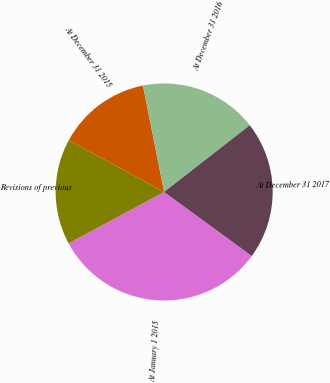Convert chart. <chart><loc_0><loc_0><loc_500><loc_500><pie_chart><fcel>At January 1 2015<fcel>Revisions of previous<fcel>At December 31 2015<fcel>At December 31 2016<fcel>At December 31 2017<nl><fcel>32.1%<fcel>15.77%<fcel>13.96%<fcel>17.59%<fcel>20.58%<nl></chart> 